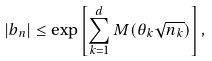Convert formula to latex. <formula><loc_0><loc_0><loc_500><loc_500>| b _ { n } | \leq \exp \left [ \sum _ { k = 1 } ^ { d } M ( \theta _ { k } \sqrt { n _ { k } } ) \right ] ,</formula> 